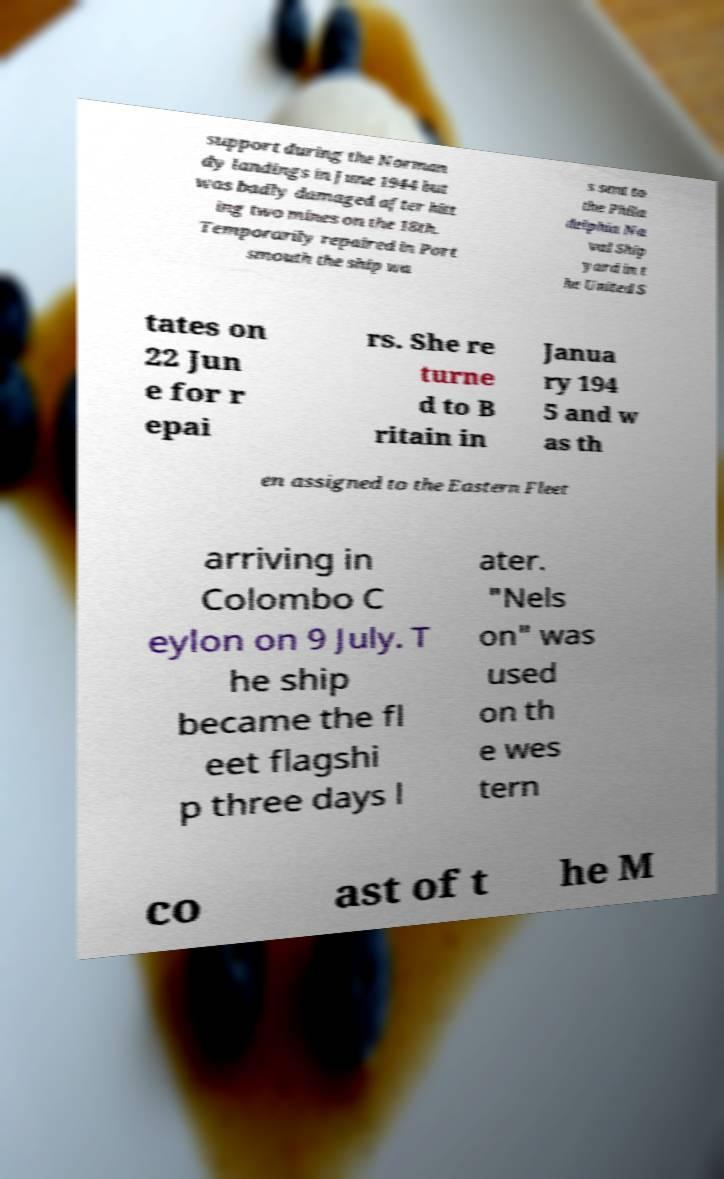Please identify and transcribe the text found in this image. support during the Norman dy landings in June 1944 but was badly damaged after hitt ing two mines on the 18th. Temporarily repaired in Port smouth the ship wa s sent to the Phila delphia Na val Ship yard in t he United S tates on 22 Jun e for r epai rs. She re turne d to B ritain in Janua ry 194 5 and w as th en assigned to the Eastern Fleet arriving in Colombo C eylon on 9 July. T he ship became the fl eet flagshi p three days l ater. "Nels on" was used on th e wes tern co ast of t he M 